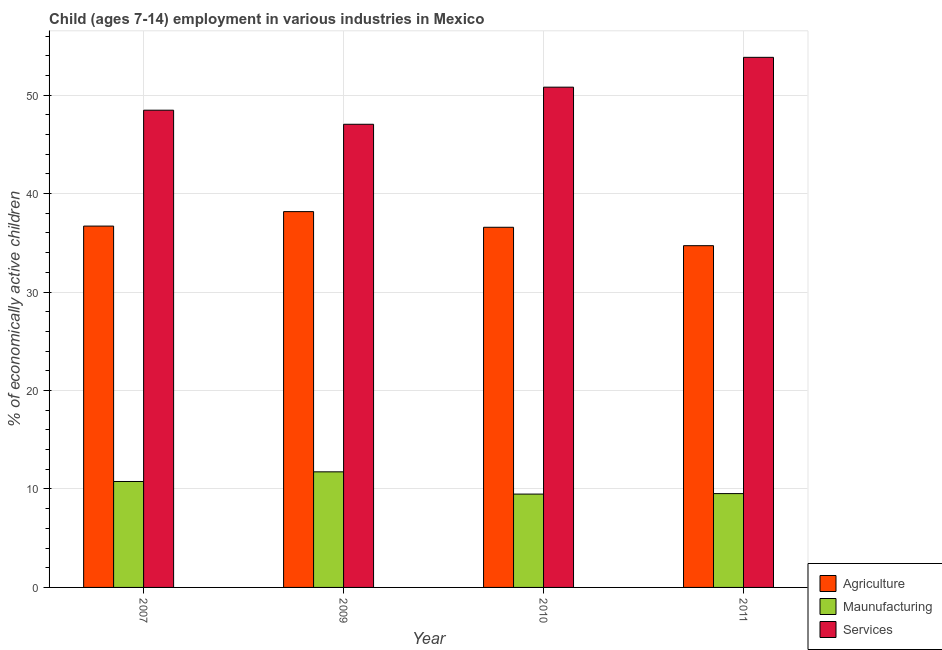How many groups of bars are there?
Ensure brevity in your answer.  4. Are the number of bars per tick equal to the number of legend labels?
Make the answer very short. Yes. How many bars are there on the 1st tick from the left?
Offer a terse response. 3. How many bars are there on the 3rd tick from the right?
Give a very brief answer. 3. What is the label of the 4th group of bars from the left?
Keep it short and to the point. 2011. In how many cases, is the number of bars for a given year not equal to the number of legend labels?
Give a very brief answer. 0. What is the percentage of economically active children in agriculture in 2007?
Give a very brief answer. 36.7. Across all years, what is the maximum percentage of economically active children in manufacturing?
Your response must be concise. 11.74. Across all years, what is the minimum percentage of economically active children in services?
Provide a short and direct response. 47.04. In which year was the percentage of economically active children in agriculture minimum?
Ensure brevity in your answer.  2011. What is the total percentage of economically active children in agriculture in the graph?
Provide a short and direct response. 146.16. What is the difference between the percentage of economically active children in manufacturing in 2009 and that in 2010?
Your answer should be compact. 2.26. What is the difference between the percentage of economically active children in services in 2011 and the percentage of economically active children in agriculture in 2009?
Ensure brevity in your answer.  6.8. What is the average percentage of economically active children in agriculture per year?
Provide a short and direct response. 36.54. In the year 2011, what is the difference between the percentage of economically active children in services and percentage of economically active children in manufacturing?
Provide a short and direct response. 0. In how many years, is the percentage of economically active children in manufacturing greater than 4 %?
Offer a very short reply. 4. What is the ratio of the percentage of economically active children in manufacturing in 2007 to that in 2009?
Your answer should be very brief. 0.92. Is the percentage of economically active children in services in 2007 less than that in 2011?
Your response must be concise. Yes. What is the difference between the highest and the second highest percentage of economically active children in agriculture?
Your answer should be compact. 1.47. What is the difference between the highest and the lowest percentage of economically active children in agriculture?
Keep it short and to the point. 3.46. Is the sum of the percentage of economically active children in manufacturing in 2007 and 2010 greater than the maximum percentage of economically active children in agriculture across all years?
Give a very brief answer. Yes. What does the 1st bar from the left in 2011 represents?
Ensure brevity in your answer.  Agriculture. What does the 1st bar from the right in 2011 represents?
Your answer should be compact. Services. Are all the bars in the graph horizontal?
Ensure brevity in your answer.  No. What is the difference between two consecutive major ticks on the Y-axis?
Provide a short and direct response. 10. Are the values on the major ticks of Y-axis written in scientific E-notation?
Your answer should be compact. No. Does the graph contain grids?
Make the answer very short. Yes. What is the title of the graph?
Provide a succinct answer. Child (ages 7-14) employment in various industries in Mexico. Does "Social Insurance" appear as one of the legend labels in the graph?
Offer a terse response. No. What is the label or title of the X-axis?
Make the answer very short. Year. What is the label or title of the Y-axis?
Ensure brevity in your answer.  % of economically active children. What is the % of economically active children in Agriculture in 2007?
Make the answer very short. 36.7. What is the % of economically active children of Maunufacturing in 2007?
Keep it short and to the point. 10.76. What is the % of economically active children of Services in 2007?
Make the answer very short. 48.47. What is the % of economically active children in Agriculture in 2009?
Your answer should be compact. 38.17. What is the % of economically active children of Maunufacturing in 2009?
Your response must be concise. 11.74. What is the % of economically active children of Services in 2009?
Give a very brief answer. 47.04. What is the % of economically active children of Agriculture in 2010?
Your answer should be very brief. 36.58. What is the % of economically active children of Maunufacturing in 2010?
Provide a succinct answer. 9.48. What is the % of economically active children of Services in 2010?
Your answer should be compact. 50.81. What is the % of economically active children of Agriculture in 2011?
Your answer should be compact. 34.71. What is the % of economically active children of Maunufacturing in 2011?
Give a very brief answer. 9.53. What is the % of economically active children in Services in 2011?
Ensure brevity in your answer.  53.84. Across all years, what is the maximum % of economically active children of Agriculture?
Make the answer very short. 38.17. Across all years, what is the maximum % of economically active children in Maunufacturing?
Give a very brief answer. 11.74. Across all years, what is the maximum % of economically active children in Services?
Your answer should be compact. 53.84. Across all years, what is the minimum % of economically active children of Agriculture?
Offer a very short reply. 34.71. Across all years, what is the minimum % of economically active children of Maunufacturing?
Your answer should be very brief. 9.48. Across all years, what is the minimum % of economically active children in Services?
Make the answer very short. 47.04. What is the total % of economically active children in Agriculture in the graph?
Provide a succinct answer. 146.16. What is the total % of economically active children of Maunufacturing in the graph?
Provide a short and direct response. 41.51. What is the total % of economically active children in Services in the graph?
Give a very brief answer. 200.16. What is the difference between the % of economically active children of Agriculture in 2007 and that in 2009?
Provide a short and direct response. -1.47. What is the difference between the % of economically active children of Maunufacturing in 2007 and that in 2009?
Give a very brief answer. -0.98. What is the difference between the % of economically active children of Services in 2007 and that in 2009?
Offer a very short reply. 1.43. What is the difference between the % of economically active children in Agriculture in 2007 and that in 2010?
Ensure brevity in your answer.  0.12. What is the difference between the % of economically active children in Maunufacturing in 2007 and that in 2010?
Make the answer very short. 1.28. What is the difference between the % of economically active children in Services in 2007 and that in 2010?
Provide a short and direct response. -2.34. What is the difference between the % of economically active children of Agriculture in 2007 and that in 2011?
Offer a terse response. 1.99. What is the difference between the % of economically active children of Maunufacturing in 2007 and that in 2011?
Provide a succinct answer. 1.23. What is the difference between the % of economically active children in Services in 2007 and that in 2011?
Your answer should be very brief. -5.37. What is the difference between the % of economically active children of Agriculture in 2009 and that in 2010?
Your answer should be very brief. 1.59. What is the difference between the % of economically active children in Maunufacturing in 2009 and that in 2010?
Give a very brief answer. 2.26. What is the difference between the % of economically active children in Services in 2009 and that in 2010?
Your response must be concise. -3.77. What is the difference between the % of economically active children in Agriculture in 2009 and that in 2011?
Offer a very short reply. 3.46. What is the difference between the % of economically active children in Maunufacturing in 2009 and that in 2011?
Make the answer very short. 2.21. What is the difference between the % of economically active children of Services in 2009 and that in 2011?
Provide a succinct answer. -6.8. What is the difference between the % of economically active children in Agriculture in 2010 and that in 2011?
Offer a terse response. 1.87. What is the difference between the % of economically active children in Services in 2010 and that in 2011?
Your answer should be very brief. -3.03. What is the difference between the % of economically active children in Agriculture in 2007 and the % of economically active children in Maunufacturing in 2009?
Keep it short and to the point. 24.96. What is the difference between the % of economically active children in Agriculture in 2007 and the % of economically active children in Services in 2009?
Offer a very short reply. -10.34. What is the difference between the % of economically active children in Maunufacturing in 2007 and the % of economically active children in Services in 2009?
Your answer should be very brief. -36.28. What is the difference between the % of economically active children of Agriculture in 2007 and the % of economically active children of Maunufacturing in 2010?
Give a very brief answer. 27.22. What is the difference between the % of economically active children in Agriculture in 2007 and the % of economically active children in Services in 2010?
Give a very brief answer. -14.11. What is the difference between the % of economically active children in Maunufacturing in 2007 and the % of economically active children in Services in 2010?
Give a very brief answer. -40.05. What is the difference between the % of economically active children in Agriculture in 2007 and the % of economically active children in Maunufacturing in 2011?
Offer a very short reply. 27.17. What is the difference between the % of economically active children in Agriculture in 2007 and the % of economically active children in Services in 2011?
Make the answer very short. -17.14. What is the difference between the % of economically active children in Maunufacturing in 2007 and the % of economically active children in Services in 2011?
Your answer should be compact. -43.08. What is the difference between the % of economically active children of Agriculture in 2009 and the % of economically active children of Maunufacturing in 2010?
Give a very brief answer. 28.69. What is the difference between the % of economically active children in Agriculture in 2009 and the % of economically active children in Services in 2010?
Your response must be concise. -12.64. What is the difference between the % of economically active children in Maunufacturing in 2009 and the % of economically active children in Services in 2010?
Offer a terse response. -39.07. What is the difference between the % of economically active children in Agriculture in 2009 and the % of economically active children in Maunufacturing in 2011?
Make the answer very short. 28.64. What is the difference between the % of economically active children in Agriculture in 2009 and the % of economically active children in Services in 2011?
Offer a terse response. -15.67. What is the difference between the % of economically active children of Maunufacturing in 2009 and the % of economically active children of Services in 2011?
Provide a succinct answer. -42.1. What is the difference between the % of economically active children in Agriculture in 2010 and the % of economically active children in Maunufacturing in 2011?
Your response must be concise. 27.05. What is the difference between the % of economically active children of Agriculture in 2010 and the % of economically active children of Services in 2011?
Your answer should be very brief. -17.26. What is the difference between the % of economically active children in Maunufacturing in 2010 and the % of economically active children in Services in 2011?
Your answer should be compact. -44.36. What is the average % of economically active children in Agriculture per year?
Ensure brevity in your answer.  36.54. What is the average % of economically active children in Maunufacturing per year?
Your answer should be compact. 10.38. What is the average % of economically active children of Services per year?
Offer a very short reply. 50.04. In the year 2007, what is the difference between the % of economically active children in Agriculture and % of economically active children in Maunufacturing?
Give a very brief answer. 25.94. In the year 2007, what is the difference between the % of economically active children of Agriculture and % of economically active children of Services?
Offer a very short reply. -11.77. In the year 2007, what is the difference between the % of economically active children of Maunufacturing and % of economically active children of Services?
Your response must be concise. -37.71. In the year 2009, what is the difference between the % of economically active children in Agriculture and % of economically active children in Maunufacturing?
Your answer should be very brief. 26.43. In the year 2009, what is the difference between the % of economically active children of Agriculture and % of economically active children of Services?
Ensure brevity in your answer.  -8.87. In the year 2009, what is the difference between the % of economically active children in Maunufacturing and % of economically active children in Services?
Your response must be concise. -35.3. In the year 2010, what is the difference between the % of economically active children of Agriculture and % of economically active children of Maunufacturing?
Ensure brevity in your answer.  27.1. In the year 2010, what is the difference between the % of economically active children in Agriculture and % of economically active children in Services?
Offer a terse response. -14.23. In the year 2010, what is the difference between the % of economically active children in Maunufacturing and % of economically active children in Services?
Keep it short and to the point. -41.33. In the year 2011, what is the difference between the % of economically active children of Agriculture and % of economically active children of Maunufacturing?
Your answer should be compact. 25.18. In the year 2011, what is the difference between the % of economically active children in Agriculture and % of economically active children in Services?
Provide a short and direct response. -19.13. In the year 2011, what is the difference between the % of economically active children of Maunufacturing and % of economically active children of Services?
Your response must be concise. -44.31. What is the ratio of the % of economically active children of Agriculture in 2007 to that in 2009?
Keep it short and to the point. 0.96. What is the ratio of the % of economically active children in Maunufacturing in 2007 to that in 2009?
Your response must be concise. 0.92. What is the ratio of the % of economically active children of Services in 2007 to that in 2009?
Provide a short and direct response. 1.03. What is the ratio of the % of economically active children in Agriculture in 2007 to that in 2010?
Give a very brief answer. 1. What is the ratio of the % of economically active children in Maunufacturing in 2007 to that in 2010?
Ensure brevity in your answer.  1.14. What is the ratio of the % of economically active children in Services in 2007 to that in 2010?
Offer a terse response. 0.95. What is the ratio of the % of economically active children in Agriculture in 2007 to that in 2011?
Offer a very short reply. 1.06. What is the ratio of the % of economically active children of Maunufacturing in 2007 to that in 2011?
Your answer should be compact. 1.13. What is the ratio of the % of economically active children of Services in 2007 to that in 2011?
Your response must be concise. 0.9. What is the ratio of the % of economically active children of Agriculture in 2009 to that in 2010?
Make the answer very short. 1.04. What is the ratio of the % of economically active children of Maunufacturing in 2009 to that in 2010?
Give a very brief answer. 1.24. What is the ratio of the % of economically active children in Services in 2009 to that in 2010?
Ensure brevity in your answer.  0.93. What is the ratio of the % of economically active children in Agriculture in 2009 to that in 2011?
Ensure brevity in your answer.  1.1. What is the ratio of the % of economically active children of Maunufacturing in 2009 to that in 2011?
Give a very brief answer. 1.23. What is the ratio of the % of economically active children in Services in 2009 to that in 2011?
Your answer should be very brief. 0.87. What is the ratio of the % of economically active children of Agriculture in 2010 to that in 2011?
Ensure brevity in your answer.  1.05. What is the ratio of the % of economically active children in Services in 2010 to that in 2011?
Your response must be concise. 0.94. What is the difference between the highest and the second highest % of economically active children in Agriculture?
Your response must be concise. 1.47. What is the difference between the highest and the second highest % of economically active children in Maunufacturing?
Provide a short and direct response. 0.98. What is the difference between the highest and the second highest % of economically active children of Services?
Ensure brevity in your answer.  3.03. What is the difference between the highest and the lowest % of economically active children of Agriculture?
Your answer should be very brief. 3.46. What is the difference between the highest and the lowest % of economically active children of Maunufacturing?
Offer a very short reply. 2.26. 